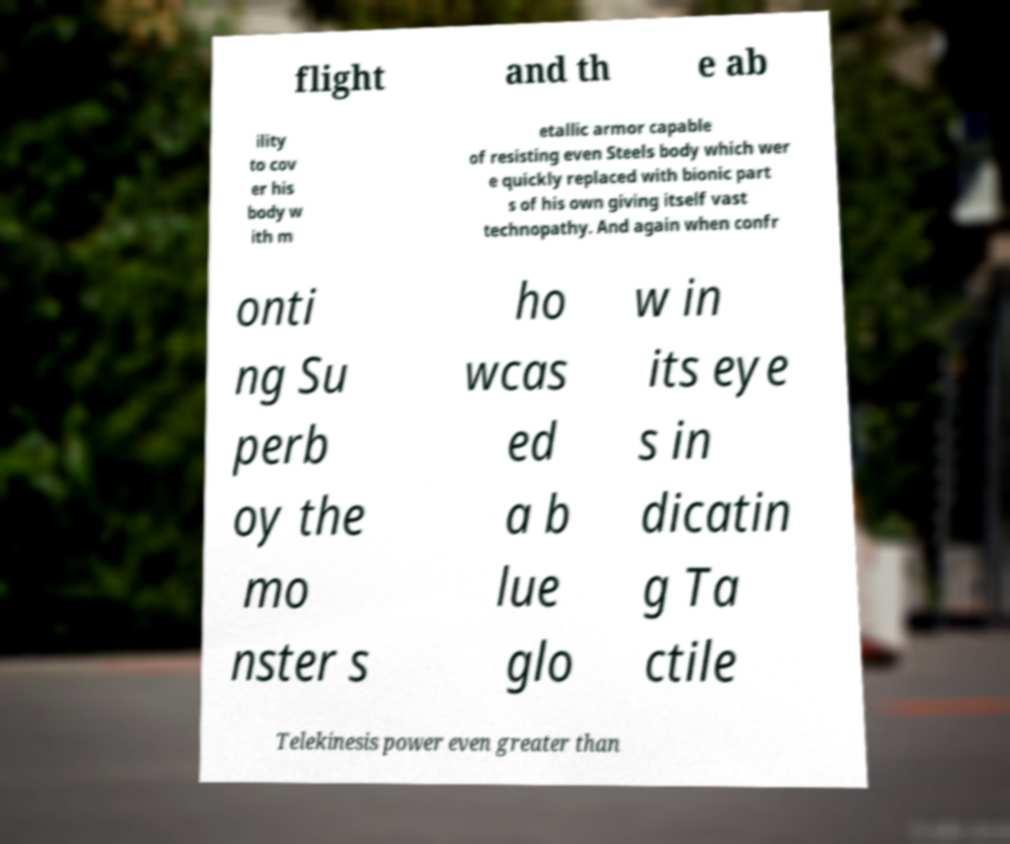I need the written content from this picture converted into text. Can you do that? flight and th e ab ility to cov er his body w ith m etallic armor capable of resisting even Steels body which wer e quickly replaced with bionic part s of his own giving itself vast technopathy. And again when confr onti ng Su perb oy the mo nster s ho wcas ed a b lue glo w in its eye s in dicatin g Ta ctile Telekinesis power even greater than 